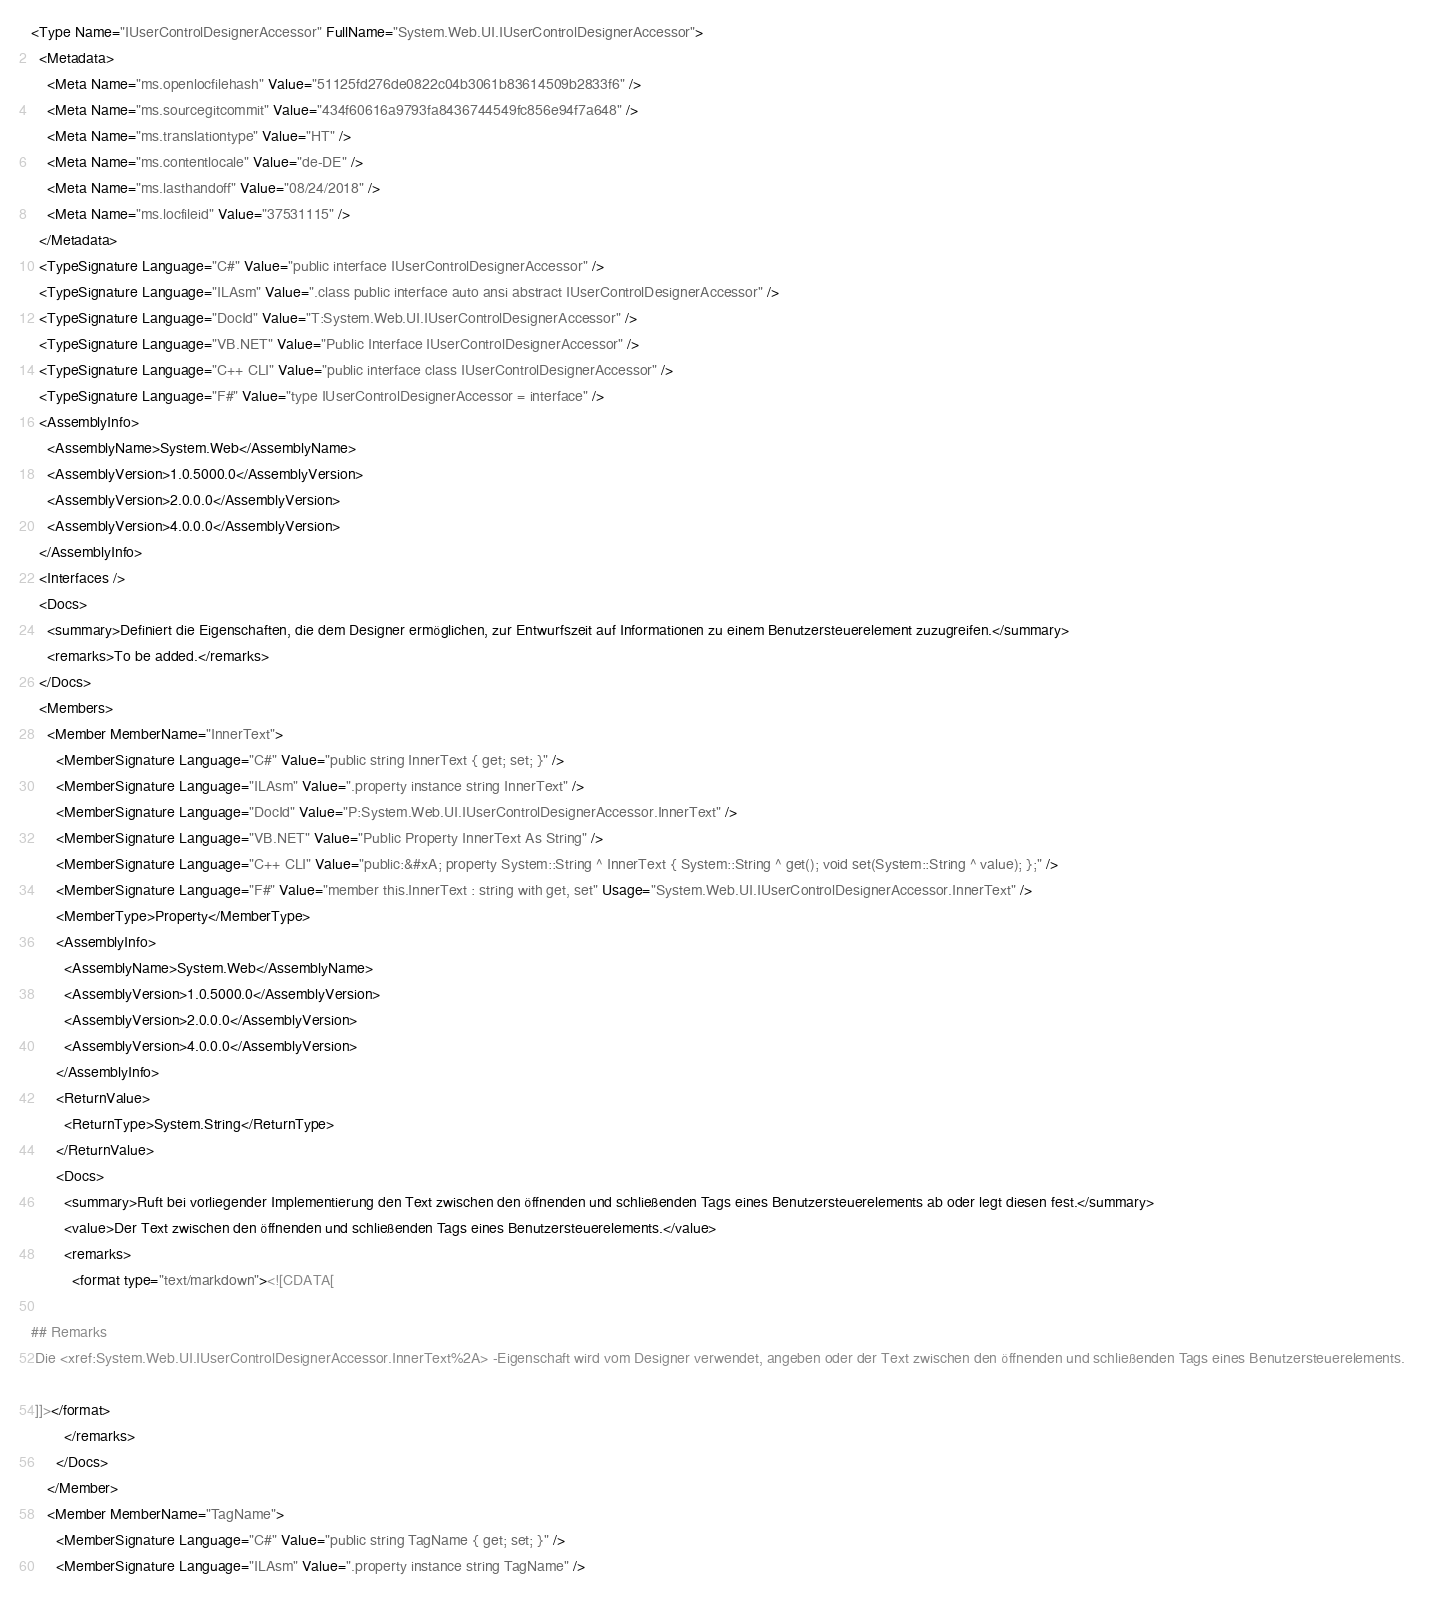Convert code to text. <code><loc_0><loc_0><loc_500><loc_500><_XML_><Type Name="IUserControlDesignerAccessor" FullName="System.Web.UI.IUserControlDesignerAccessor">
  <Metadata>
    <Meta Name="ms.openlocfilehash" Value="51125fd276de0822c04b3061b83614509b2833f6" />
    <Meta Name="ms.sourcegitcommit" Value="434f60616a9793fa8436744549fc856e94f7a648" />
    <Meta Name="ms.translationtype" Value="HT" />
    <Meta Name="ms.contentlocale" Value="de-DE" />
    <Meta Name="ms.lasthandoff" Value="08/24/2018" />
    <Meta Name="ms.locfileid" Value="37531115" />
  </Metadata>
  <TypeSignature Language="C#" Value="public interface IUserControlDesignerAccessor" />
  <TypeSignature Language="ILAsm" Value=".class public interface auto ansi abstract IUserControlDesignerAccessor" />
  <TypeSignature Language="DocId" Value="T:System.Web.UI.IUserControlDesignerAccessor" />
  <TypeSignature Language="VB.NET" Value="Public Interface IUserControlDesignerAccessor" />
  <TypeSignature Language="C++ CLI" Value="public interface class IUserControlDesignerAccessor" />
  <TypeSignature Language="F#" Value="type IUserControlDesignerAccessor = interface" />
  <AssemblyInfo>
    <AssemblyName>System.Web</AssemblyName>
    <AssemblyVersion>1.0.5000.0</AssemblyVersion>
    <AssemblyVersion>2.0.0.0</AssemblyVersion>
    <AssemblyVersion>4.0.0.0</AssemblyVersion>
  </AssemblyInfo>
  <Interfaces />
  <Docs>
    <summary>Definiert die Eigenschaften, die dem Designer ermöglichen, zur Entwurfszeit auf Informationen zu einem Benutzersteuerelement zuzugreifen.</summary>
    <remarks>To be added.</remarks>
  </Docs>
  <Members>
    <Member MemberName="InnerText">
      <MemberSignature Language="C#" Value="public string InnerText { get; set; }" />
      <MemberSignature Language="ILAsm" Value=".property instance string InnerText" />
      <MemberSignature Language="DocId" Value="P:System.Web.UI.IUserControlDesignerAccessor.InnerText" />
      <MemberSignature Language="VB.NET" Value="Public Property InnerText As String" />
      <MemberSignature Language="C++ CLI" Value="public:&#xA; property System::String ^ InnerText { System::String ^ get(); void set(System::String ^ value); };" />
      <MemberSignature Language="F#" Value="member this.InnerText : string with get, set" Usage="System.Web.UI.IUserControlDesignerAccessor.InnerText" />
      <MemberType>Property</MemberType>
      <AssemblyInfo>
        <AssemblyName>System.Web</AssemblyName>
        <AssemblyVersion>1.0.5000.0</AssemblyVersion>
        <AssemblyVersion>2.0.0.0</AssemblyVersion>
        <AssemblyVersion>4.0.0.0</AssemblyVersion>
      </AssemblyInfo>
      <ReturnValue>
        <ReturnType>System.String</ReturnType>
      </ReturnValue>
      <Docs>
        <summary>Ruft bei vorliegender Implementierung den Text zwischen den öffnenden und schließenden Tags eines Benutzersteuerelements ab oder legt diesen fest.</summary>
        <value>Der Text zwischen den öffnenden und schließenden Tags eines Benutzersteuerelements.</value>
        <remarks>
          <format type="text/markdown"><![CDATA[  
  
## Remarks  
 Die <xref:System.Web.UI.IUserControlDesignerAccessor.InnerText%2A> -Eigenschaft wird vom Designer verwendet, angeben oder der Text zwischen den öffnenden und schließenden Tags eines Benutzersteuerelements.  
  
 ]]></format>
        </remarks>
      </Docs>
    </Member>
    <Member MemberName="TagName">
      <MemberSignature Language="C#" Value="public string TagName { get; set; }" />
      <MemberSignature Language="ILAsm" Value=".property instance string TagName" /></code> 